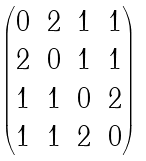<formula> <loc_0><loc_0><loc_500><loc_500>\begin{pmatrix} 0 & 2 & 1 & 1 \\ 2 & 0 & 1 & 1 \\ 1 & 1 & 0 & 2 \\ 1 & 1 & 2 & 0 \end{pmatrix}</formula> 